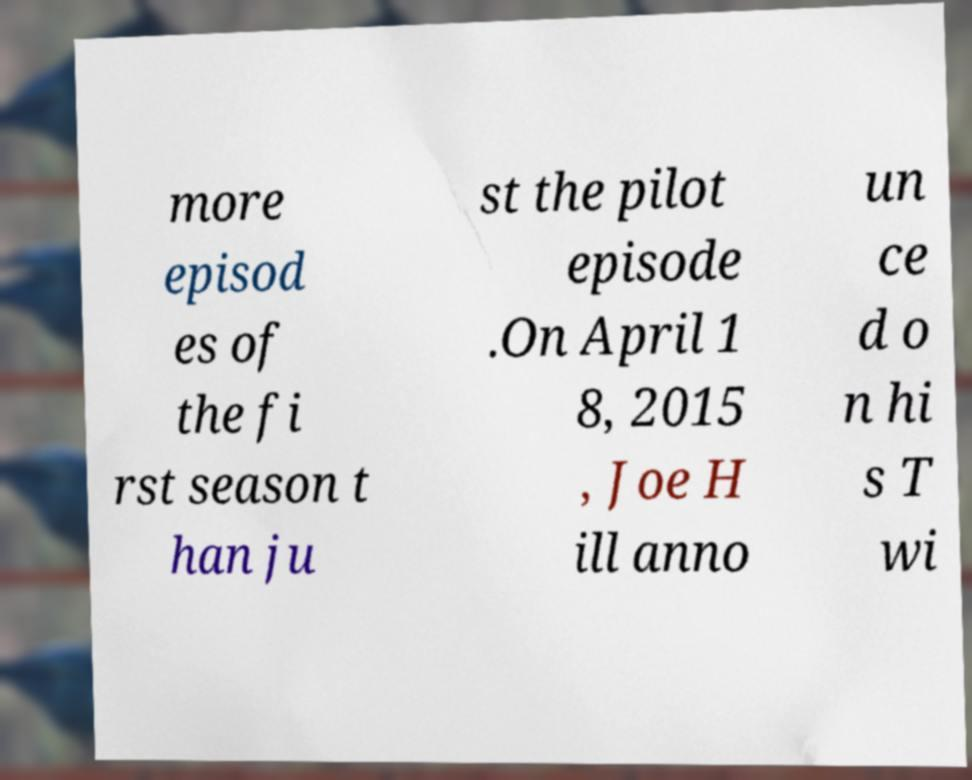I need the written content from this picture converted into text. Can you do that? more episod es of the fi rst season t han ju st the pilot episode .On April 1 8, 2015 , Joe H ill anno un ce d o n hi s T wi 